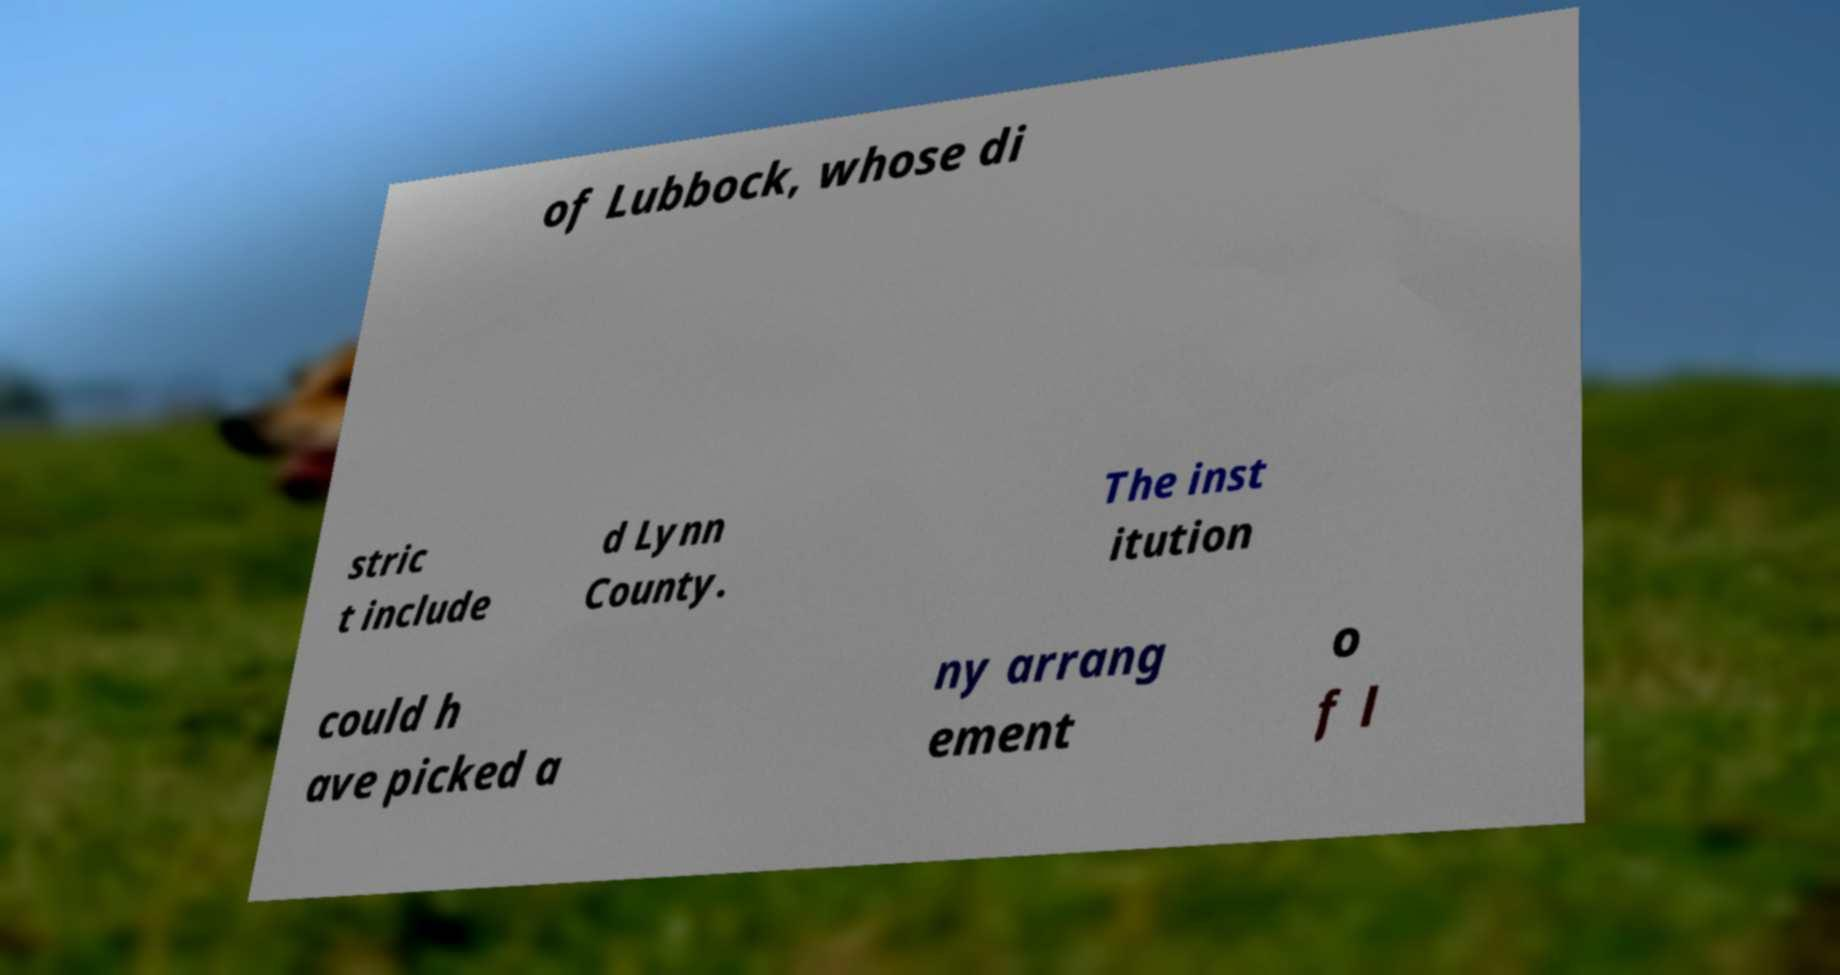Could you extract and type out the text from this image? of Lubbock, whose di stric t include d Lynn County. The inst itution could h ave picked a ny arrang ement o f l 